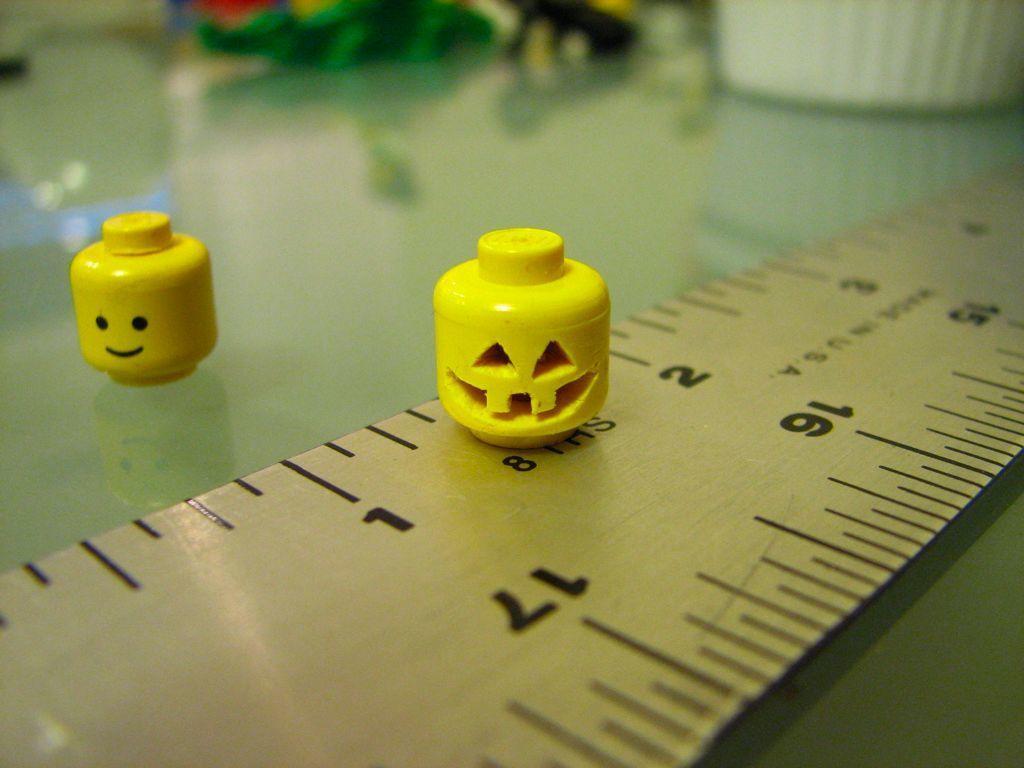How would you summarize this image in a sentence or two? In the foreground of this image, in the middle, there is a yellow color object on a scale. Beside it, there is another yellow color object on the glass. At the top, there are few objects. 